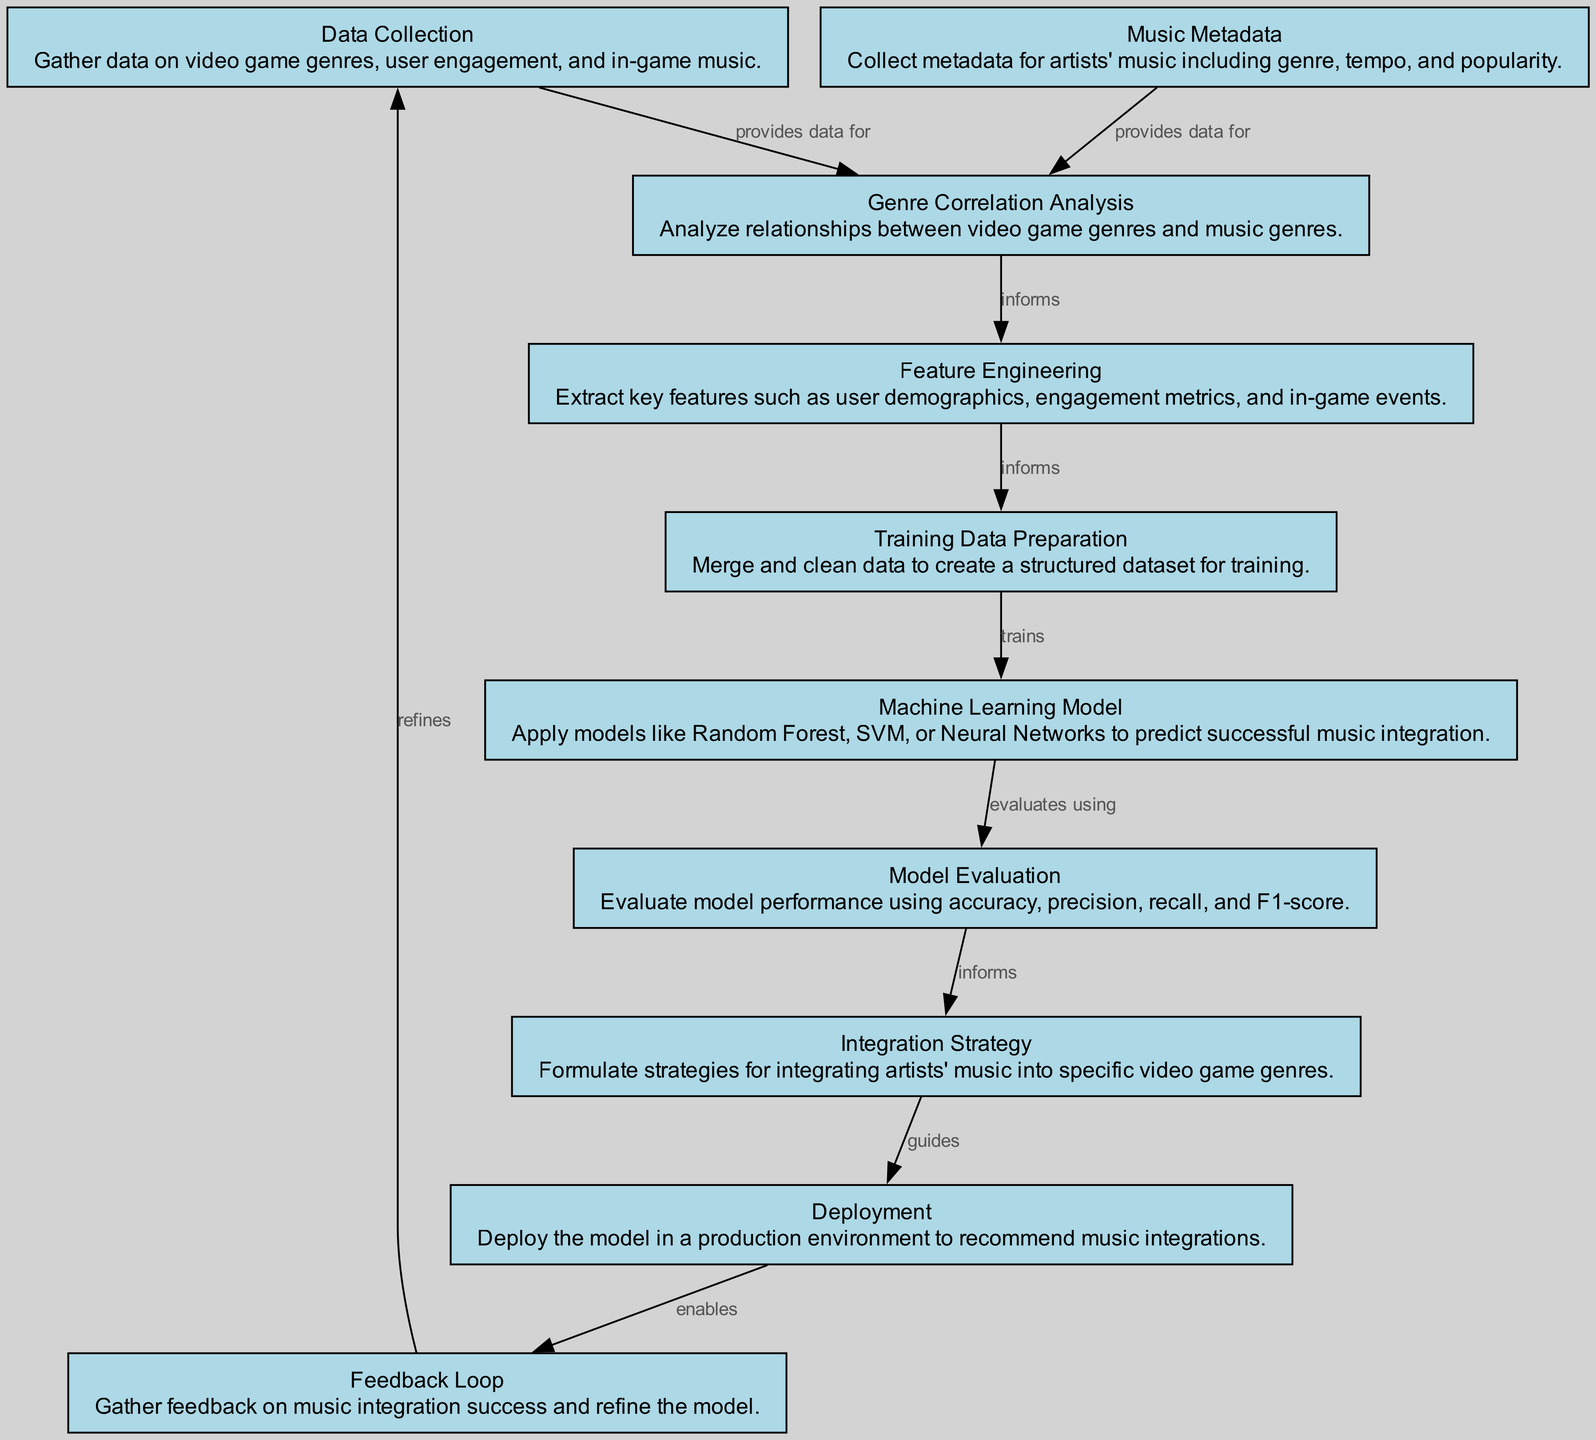What is the first node in the diagram? The first node is "Data Collection." This can be identified as it is the starting point of the flow, with no other node leading into it.
Answer: Data Collection How many nodes are in the diagram? By counting all the distinct nodes present in the diagram, there are 10 nodes labeled from 1 to 10.
Answer: 10 Which node evaluates the model performance? The node labeled "Model Evaluation" is responsible for evaluating the model's performance using various metrics. This is explicitly stated in its description.
Answer: Model Evaluation What relationship does "Music Metadata" have with "Genre Correlation Analysis"? "Music Metadata" provides data for "Genre Correlation Analysis." This is indicated by the directed edge that connects these two nodes with the label "provides data for."
Answer: provides data for Which node directly leads to the creation of training data? The "Training Data Preparation" node is directly preceded by the nodes "Feature Engineering," which informs it. This describes the flow of information leading into "Training Data Preparation."
Answer: Training Data Preparation What is the last node in the diagram? The last node is "Feedback Loop," which is the final point in the flow, suggesting that it gathers feedback and refines the model based on prior nodes.
Answer: Feedback Loop Which models could potentially be applied according to the diagram? The "Machine Learning Model" node mentions applying models like Random Forest, SVM, or Neural Networks. This indicates several options listed in its description.
Answer: Random Forest, SVM, Neural Networks What does "Integration Strategy" inform? The "Integration Strategy" is informed by "Model Evaluation," as indicated by the directed edge and the label "informs," showing the dependency on evaluation results.
Answer: Model Evaluation How does the "Feedback Loop" impact the process? The "Feedback Loop" enables the gathering of feedback on music integration success, which in turn refines the model, showing a cyclical improvement process based on feedback.
Answer: refines 